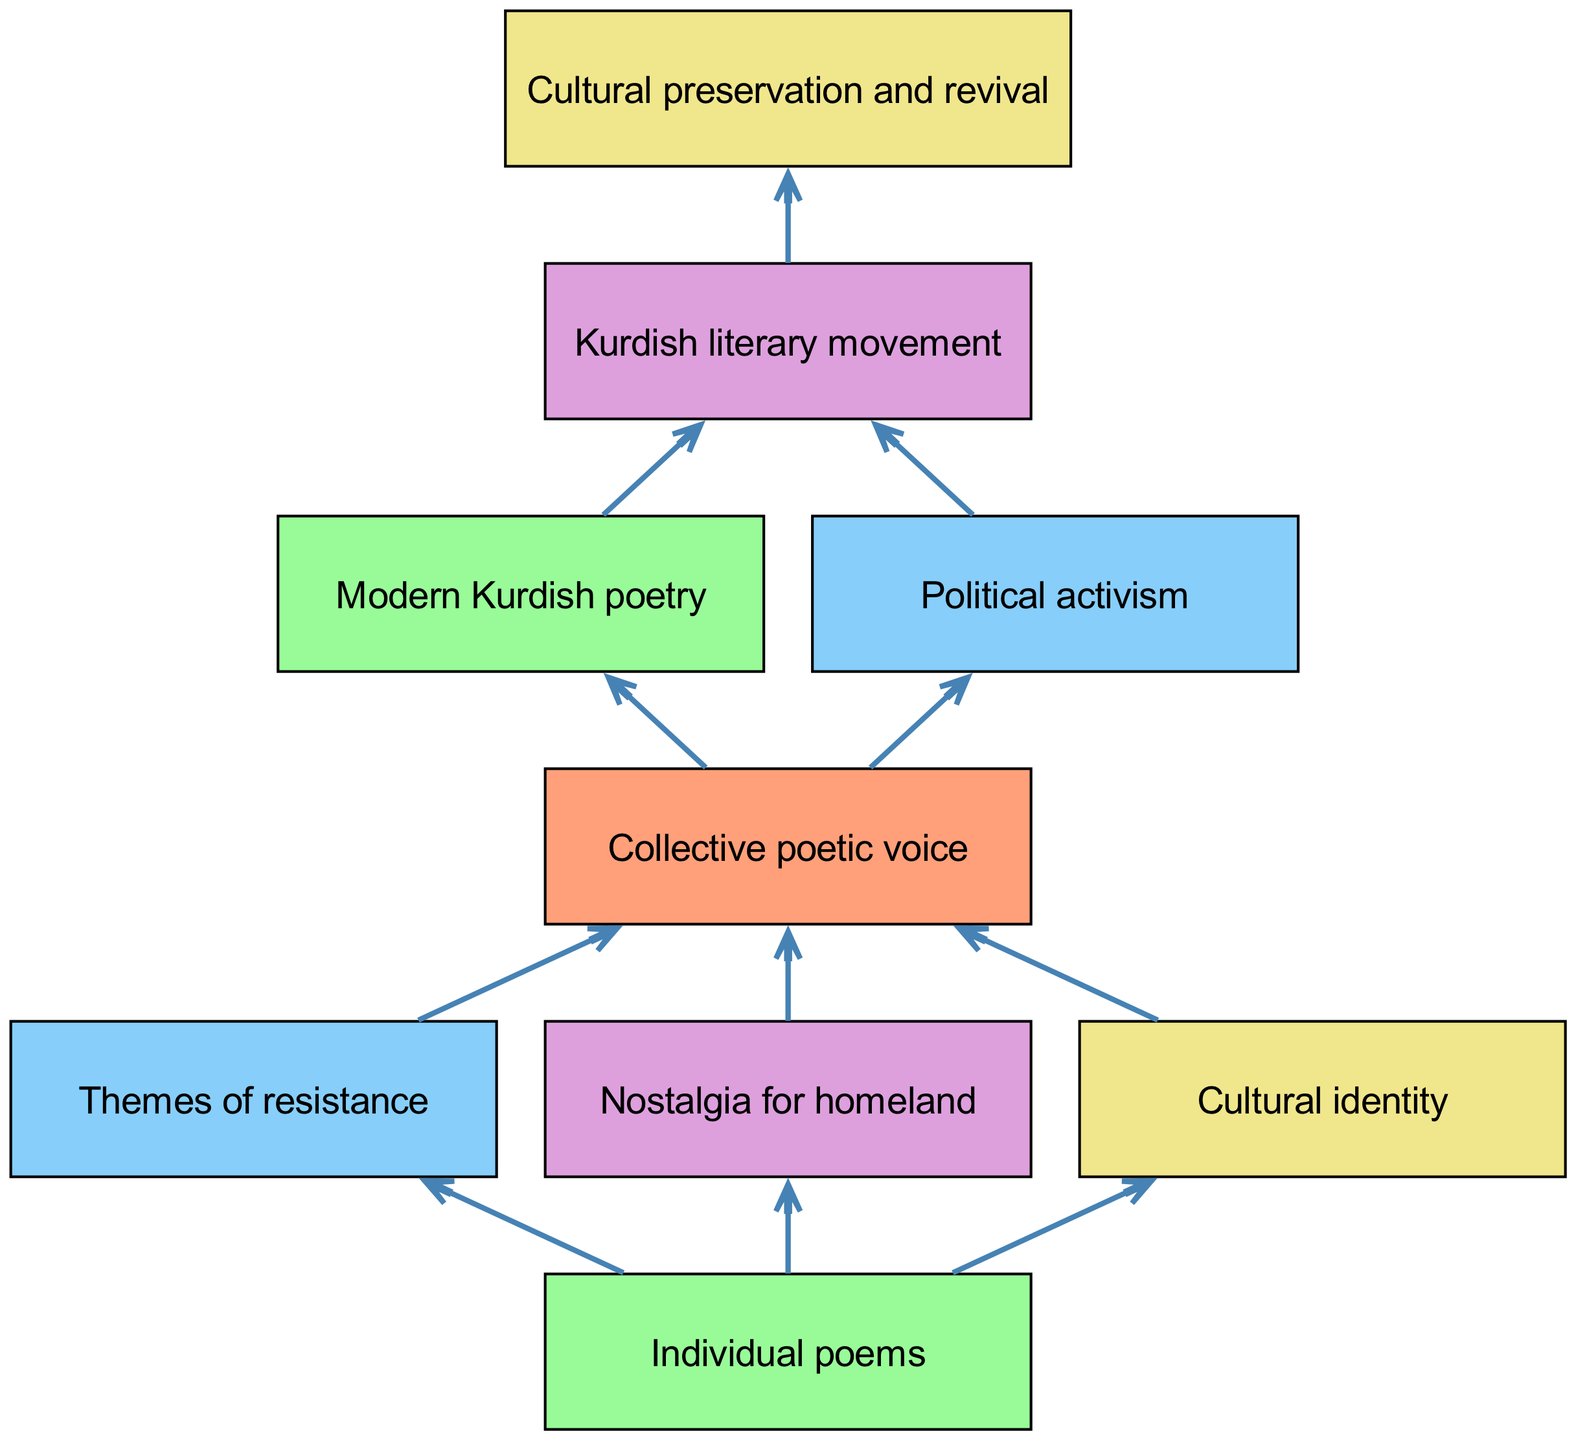What's at the top of the diagram? The top element in the diagram is "Individual poems," which serves as the starting point for the flow chart, indicating the focus on poems influenced by various movements.
Answer: Individual poems How many themes are directly under "Individual poems"? There are three children nodes directly under "Individual poems": "Themes of resistance," "Nostalgia for homeland," and "Cultural identity." So, the count is three.
Answer: 3 What is the final outcome of the flow chart? The final node of the flow chart is "Cultural preservation and revival," which represents the ultimate impact of the discussed themes and movements on Kurdish poetry.
Answer: Cultural preservation and revival Which node connects "Political activism" to the overall poetic impact? "Political activism" connects to "Kurdish literary movement," indicating that activism is an aspect contributing to the broader literary movements within Kurdish poetry.
Answer: Kurdish literary movement What are the children of "Collective poetic voice"? The children of "Collective poetic voice" are "Modern Kurdish poetry" and "Political activism," highlighting the aspects emanating from a unified voice in the poetry.
Answer: Modern Kurdish poetry, Political activism How do "Themes of resistance" and "Nostalgia for homeland" contribute to the same outcome? Both "Themes of resistance" and "Nostalgia for homeland" lead to the "Collective poetic voice," which is the shared expression resulting from these individual themes.
Answer: Collective poetic voice Which node acts as a bridge between themes and the broader movement? "Collective poetic voice" serves as the bridge connecting individual themes like resistance and nostalgia to the larger context of the Kurdish literary movement and cultural revival.
Answer: Collective poetic voice How many edges are in the diagram? By counting the arrows connecting nodes in the diagram, there are a total of eight directed edges representing the flow of influence between themes and outcomes.
Answer: 8 